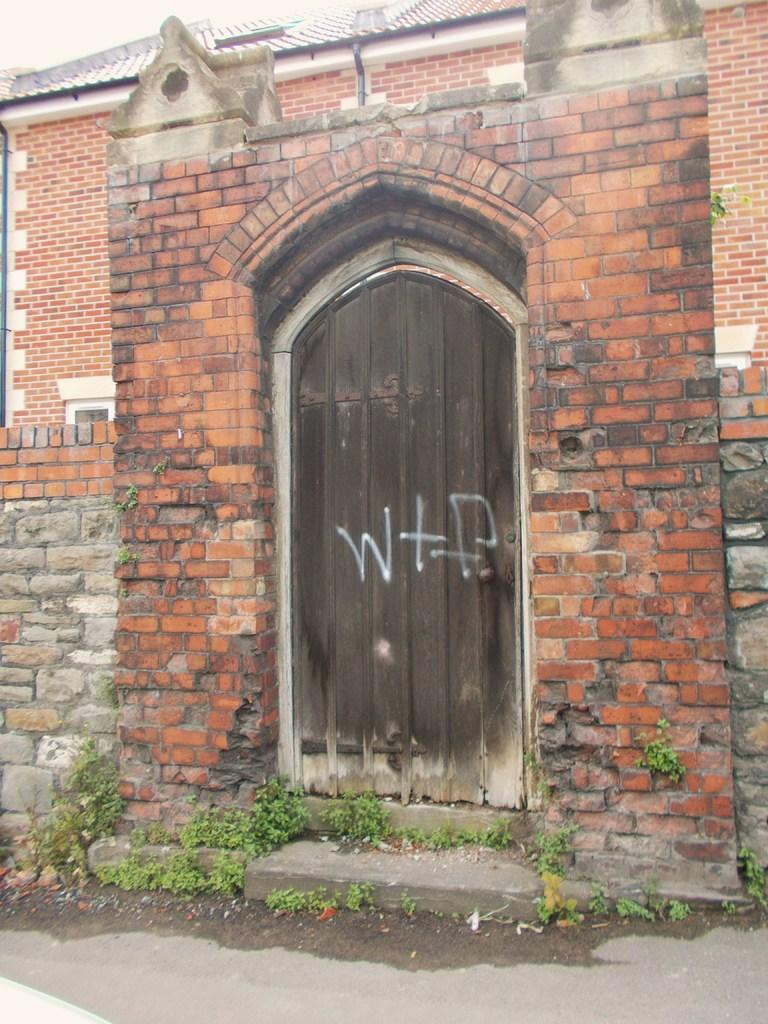What type of structure is in the image? There is a building in the image. What features of the building can be identified? The building has a door, pipes, and a roof. What is located in the foreground of the image? There are plants in the foreground of the image. What is visible at the top of the image? The sky is visible at the top of the image. What type of print can be seen on the door of the building in the image? There is no print visible on the door of the building in the image. How many pieces of advice are given by the plants in the foreground of the image? There are no pieces of advice given by the plants in the image, as plants do not communicate in this manner. 